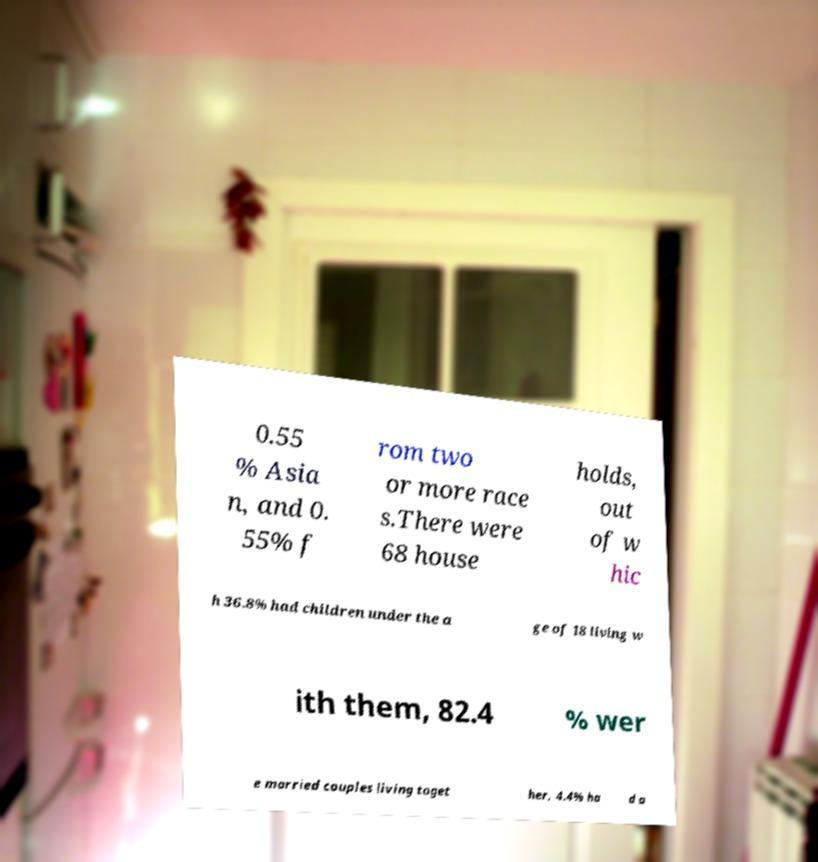What messages or text are displayed in this image? I need them in a readable, typed format. 0.55 % Asia n, and 0. 55% f rom two or more race s.There were 68 house holds, out of w hic h 36.8% had children under the a ge of 18 living w ith them, 82.4 % wer e married couples living toget her, 4.4% ha d a 